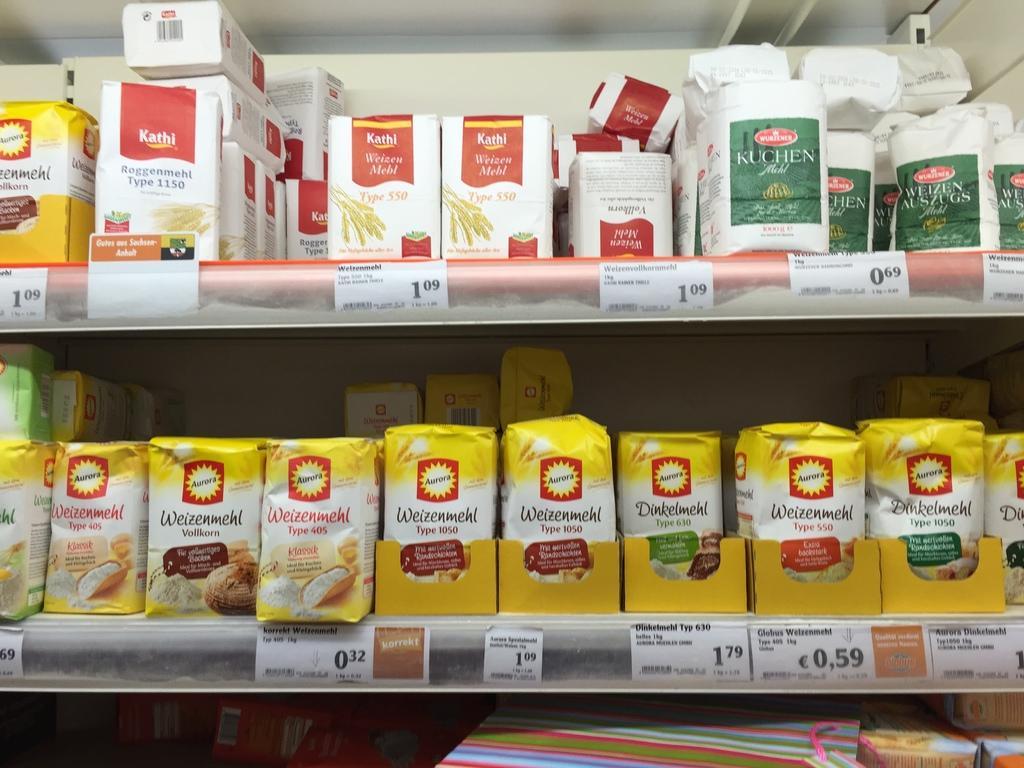Can you describe this image briefly? In this image, we can see some shelves with objects. We can also see some price tags on the shelves. 